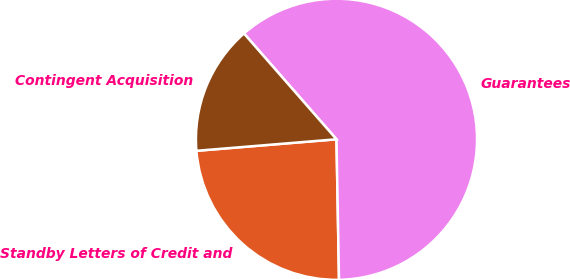Convert chart to OTSL. <chart><loc_0><loc_0><loc_500><loc_500><pie_chart><fcel>Standby Letters of Credit and<fcel>Guarantees<fcel>Contingent Acquisition<nl><fcel>23.98%<fcel>61.15%<fcel>14.87%<nl></chart> 